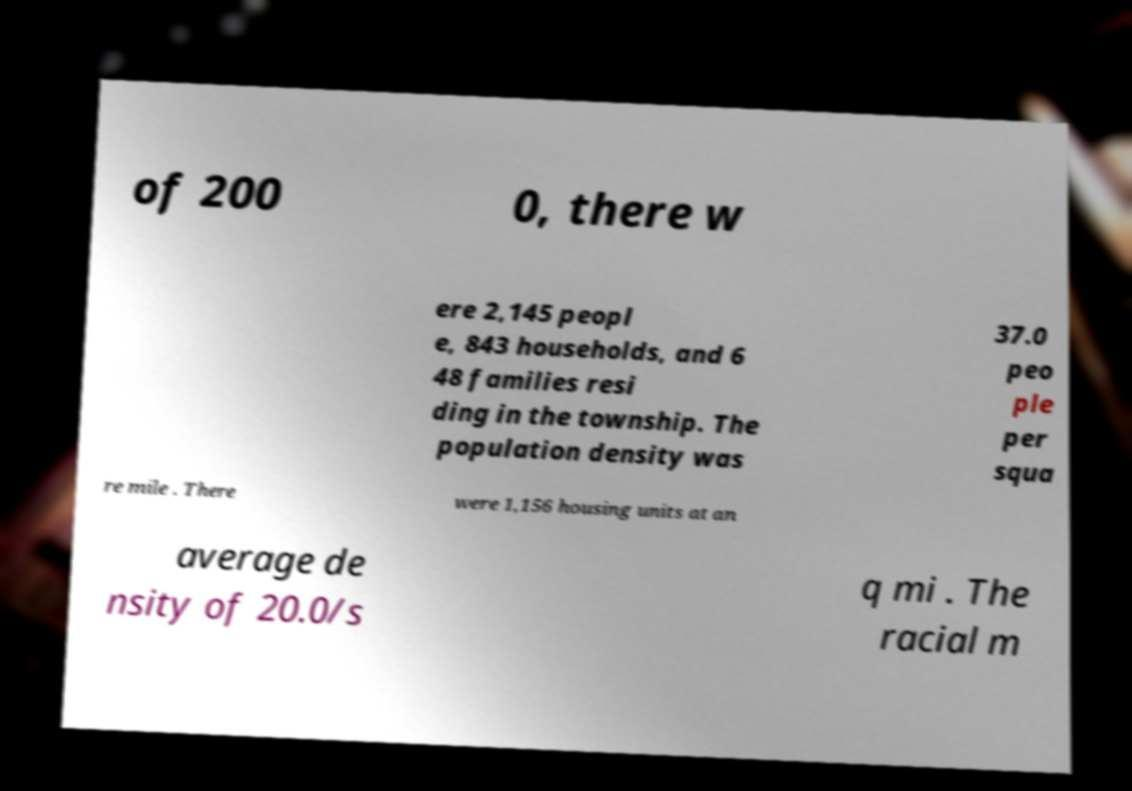Please read and relay the text visible in this image. What does it say? of 200 0, there w ere 2,145 peopl e, 843 households, and 6 48 families resi ding in the township. The population density was 37.0 peo ple per squa re mile . There were 1,156 housing units at an average de nsity of 20.0/s q mi . The racial m 